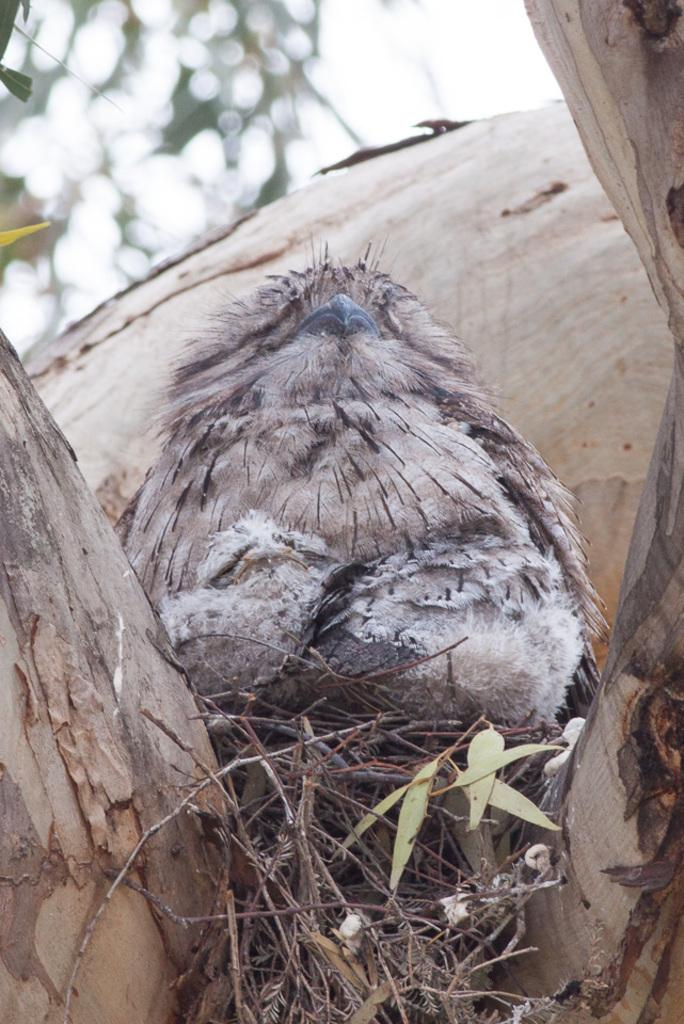What animal can be seen in the image? There is a bird on a tree in the image. Where is the bird located in the image? The bird is on a tree in the image. What can be seen in the background of the image? There is a sky visible in the background of the image. What type of mask is the bird wearing in the image? There is no mask present on the bird in the image. Can you describe the gate that the bird is standing next to in the image? There is no gate present in the image; the bird is on a tree. 